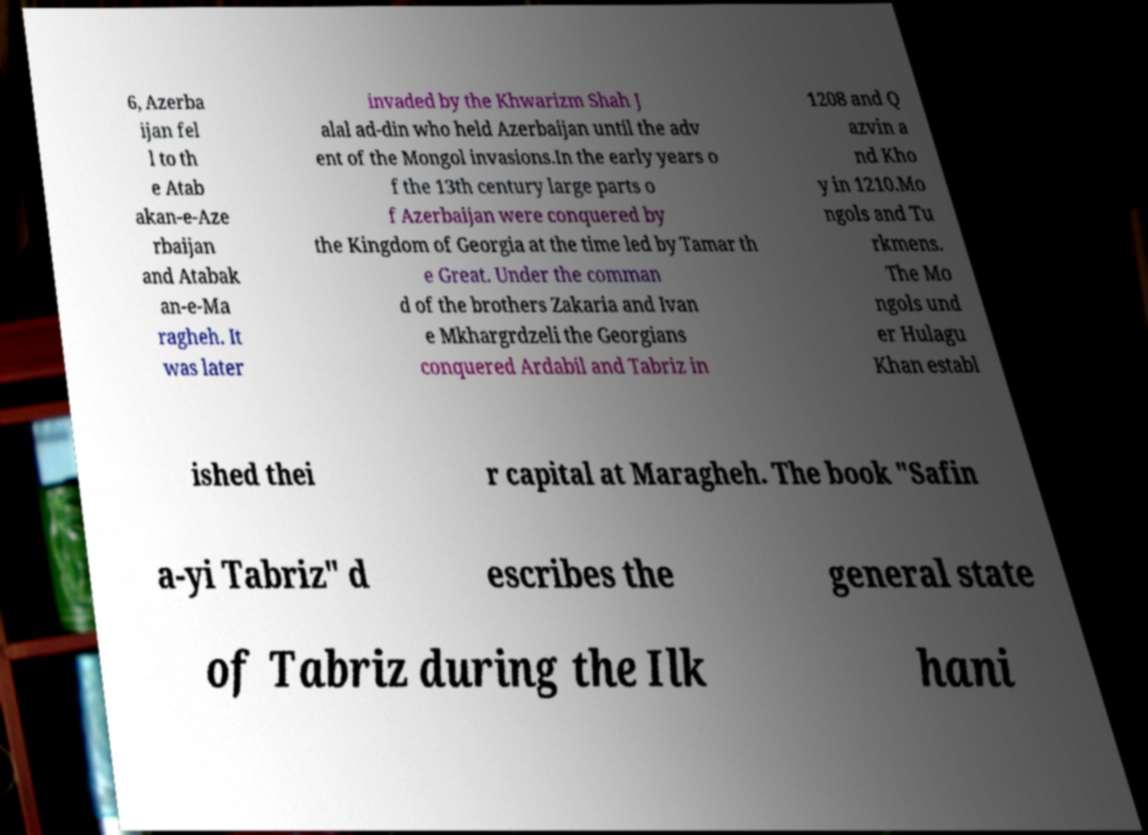Can you accurately transcribe the text from the provided image for me? 6, Azerba ijan fel l to th e Atab akan-e-Aze rbaijan and Atabak an-e-Ma ragheh. It was later invaded by the Khwarizm Shah J alal ad-din who held Azerbaijan until the adv ent of the Mongol invasions.In the early years o f the 13th century large parts o f Azerbaijan were conquered by the Kingdom of Georgia at the time led by Tamar th e Great. Under the comman d of the brothers Zakaria and Ivan e Mkhargrdzeli the Georgians conquered Ardabil and Tabriz in 1208 and Q azvin a nd Kho y in 1210.Mo ngols and Tu rkmens. The Mo ngols und er Hulagu Khan establ ished thei r capital at Maragheh. The book "Safin a-yi Tabriz" d escribes the general state of Tabriz during the Ilk hani 